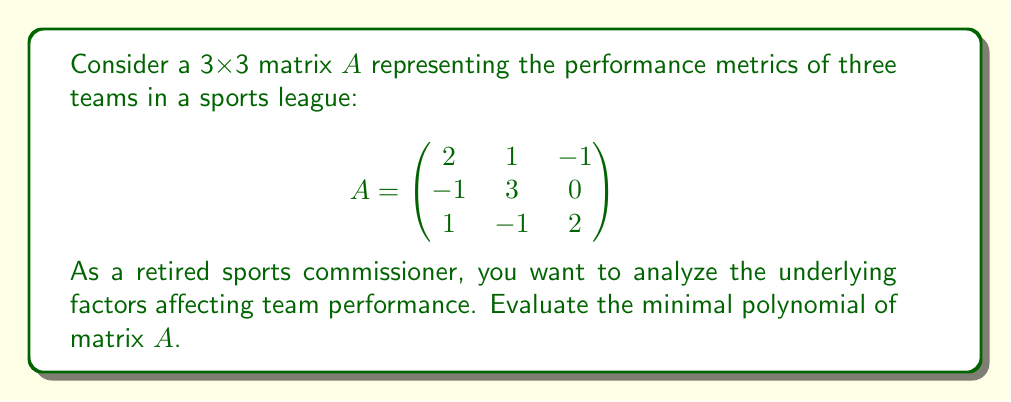Solve this math problem. To find the minimal polynomial of matrix $A$, we'll follow these steps:

1) First, calculate the characteristic polynomial of $A$:
   $p(x) = \det(xI - A)$
   
   $$\det\begin{pmatrix}
   x-2 & -1 & 1 \\
   1 & x-3 & 0 \\
   -1 & 1 & x-2
   \end{pmatrix}$$

2) Expanding the determinant:
   $p(x) = (x-2)[(x-3)(x-2) - 0] + (-1)[1(x-2) - (-1)] + 1[1 \cdot 0 - (x-3)]$
   $p(x) = (x-2)(x^2-5x+6) + (-1)(x-1) + (3-x)$
   $p(x) = x^3-5x^2+6x-2x^2+10x-12-x+1+3-x$
   $p(x) = x^3-7x^2+14x-8$

3) Now, we need to check if this is also the minimal polynomial. We do this by testing if any lower degree polynomial annihilates $A$.

4) Let's check if $A$ satisfies its own characteristic equation:
   $A^3-7A^2+14A-8I = 0$

5) If this equality holds, then the characteristic polynomial is also the minimal polynomial.

6) Calculate $A^2$ and $A^3$:
   
   $A^2 = \begin{pmatrix}
   3 & 1 & -3 \\
   -5 & 8 & 1 \\
   3 & -1 & 3
   \end{pmatrix}$

   $A^3 = \begin{pmatrix}
   1 & 5 & -3 \\
   -13 & 21 & 5 \\
   7 & -5 & 1
   \end{pmatrix}$

7) Substitute into the equation:
   $A^3-7A^2+14A-8I = 0$
   
   This equality holds, confirming that the characteristic polynomial is indeed the minimal polynomial.

Therefore, the minimal polynomial of $A$ is $x^3-7x^2+14x-8$.
Answer: $x^3-7x^2+14x-8$ 